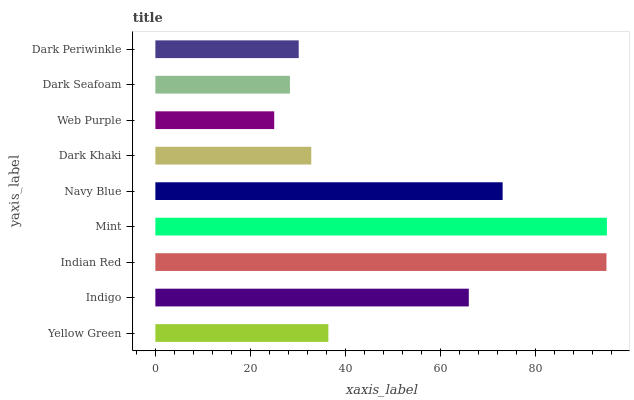Is Web Purple the minimum?
Answer yes or no. Yes. Is Mint the maximum?
Answer yes or no. Yes. Is Indigo the minimum?
Answer yes or no. No. Is Indigo the maximum?
Answer yes or no. No. Is Indigo greater than Yellow Green?
Answer yes or no. Yes. Is Yellow Green less than Indigo?
Answer yes or no. Yes. Is Yellow Green greater than Indigo?
Answer yes or no. No. Is Indigo less than Yellow Green?
Answer yes or no. No. Is Yellow Green the high median?
Answer yes or no. Yes. Is Yellow Green the low median?
Answer yes or no. Yes. Is Indian Red the high median?
Answer yes or no. No. Is Dark Khaki the low median?
Answer yes or no. No. 